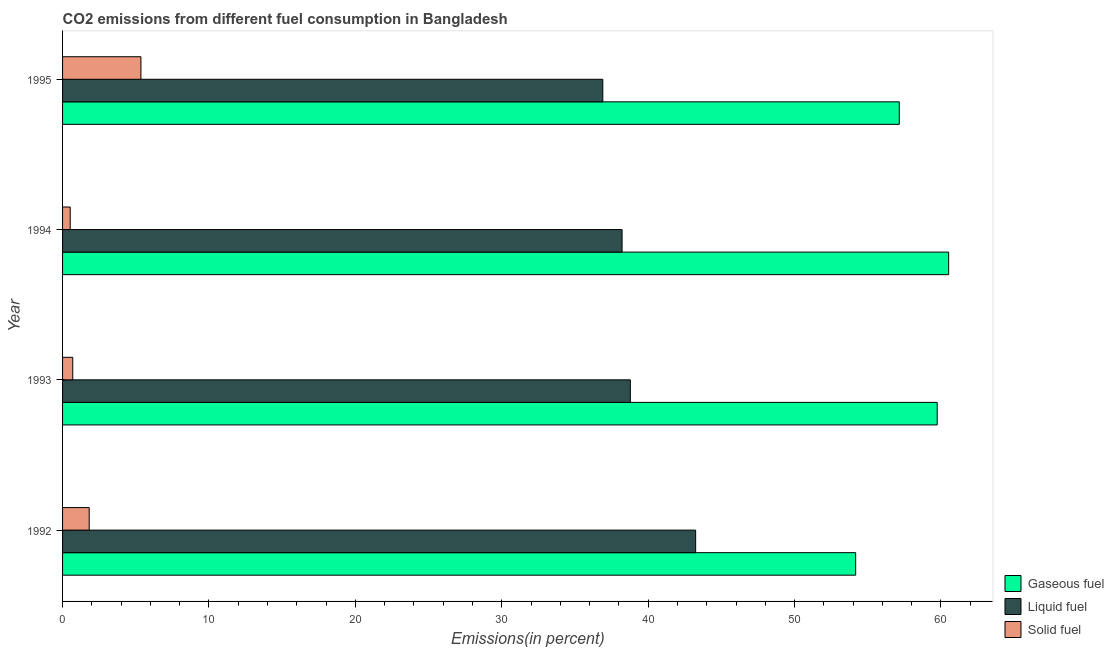How many different coloured bars are there?
Ensure brevity in your answer.  3. How many groups of bars are there?
Offer a very short reply. 4. Are the number of bars per tick equal to the number of legend labels?
Offer a very short reply. Yes. How many bars are there on the 2nd tick from the top?
Offer a very short reply. 3. How many bars are there on the 3rd tick from the bottom?
Provide a short and direct response. 3. What is the label of the 4th group of bars from the top?
Offer a very short reply. 1992. In how many cases, is the number of bars for a given year not equal to the number of legend labels?
Give a very brief answer. 0. What is the percentage of solid fuel emission in 1992?
Provide a short and direct response. 1.82. Across all years, what is the maximum percentage of solid fuel emission?
Offer a very short reply. 5.35. Across all years, what is the minimum percentage of solid fuel emission?
Your answer should be compact. 0.52. What is the total percentage of gaseous fuel emission in the graph?
Make the answer very short. 231.59. What is the difference between the percentage of liquid fuel emission in 1992 and that in 1995?
Provide a succinct answer. 6.34. What is the difference between the percentage of solid fuel emission in 1992 and the percentage of gaseous fuel emission in 1995?
Keep it short and to the point. -55.33. What is the average percentage of solid fuel emission per year?
Keep it short and to the point. 2.1. In the year 1992, what is the difference between the percentage of liquid fuel emission and percentage of gaseous fuel emission?
Keep it short and to the point. -10.93. What is the ratio of the percentage of gaseous fuel emission in 1993 to that in 1994?
Offer a very short reply. 0.99. What is the difference between the highest and the second highest percentage of gaseous fuel emission?
Keep it short and to the point. 0.78. What is the difference between the highest and the lowest percentage of solid fuel emission?
Your answer should be compact. 4.83. Is the sum of the percentage of liquid fuel emission in 1994 and 1995 greater than the maximum percentage of solid fuel emission across all years?
Provide a short and direct response. Yes. What does the 3rd bar from the top in 1992 represents?
Your response must be concise. Gaseous fuel. What does the 3rd bar from the bottom in 1993 represents?
Provide a succinct answer. Solid fuel. Is it the case that in every year, the sum of the percentage of gaseous fuel emission and percentage of liquid fuel emission is greater than the percentage of solid fuel emission?
Your response must be concise. Yes. Are all the bars in the graph horizontal?
Your answer should be compact. Yes. What is the difference between two consecutive major ticks on the X-axis?
Make the answer very short. 10. Does the graph contain any zero values?
Ensure brevity in your answer.  No. Where does the legend appear in the graph?
Your answer should be very brief. Bottom right. How many legend labels are there?
Give a very brief answer. 3. How are the legend labels stacked?
Offer a very short reply. Vertical. What is the title of the graph?
Give a very brief answer. CO2 emissions from different fuel consumption in Bangladesh. What is the label or title of the X-axis?
Provide a short and direct response. Emissions(in percent). What is the Emissions(in percent) of Gaseous fuel in 1992?
Provide a short and direct response. 54.17. What is the Emissions(in percent) of Liquid fuel in 1992?
Keep it short and to the point. 43.24. What is the Emissions(in percent) of Solid fuel in 1992?
Your response must be concise. 1.82. What is the Emissions(in percent) in Gaseous fuel in 1993?
Provide a succinct answer. 59.74. What is the Emissions(in percent) of Liquid fuel in 1993?
Your answer should be compact. 38.78. What is the Emissions(in percent) of Solid fuel in 1993?
Keep it short and to the point. 0.7. What is the Emissions(in percent) of Gaseous fuel in 1994?
Offer a very short reply. 60.53. What is the Emissions(in percent) in Liquid fuel in 1994?
Your answer should be compact. 38.22. What is the Emissions(in percent) in Solid fuel in 1994?
Provide a short and direct response. 0.52. What is the Emissions(in percent) of Gaseous fuel in 1995?
Give a very brief answer. 57.15. What is the Emissions(in percent) of Liquid fuel in 1995?
Your answer should be compact. 36.9. What is the Emissions(in percent) of Solid fuel in 1995?
Give a very brief answer. 5.35. Across all years, what is the maximum Emissions(in percent) in Gaseous fuel?
Ensure brevity in your answer.  60.53. Across all years, what is the maximum Emissions(in percent) in Liquid fuel?
Keep it short and to the point. 43.24. Across all years, what is the maximum Emissions(in percent) in Solid fuel?
Give a very brief answer. 5.35. Across all years, what is the minimum Emissions(in percent) of Gaseous fuel?
Offer a very short reply. 54.17. Across all years, what is the minimum Emissions(in percent) in Liquid fuel?
Make the answer very short. 36.9. Across all years, what is the minimum Emissions(in percent) in Solid fuel?
Offer a very short reply. 0.52. What is the total Emissions(in percent) of Gaseous fuel in the graph?
Offer a very short reply. 231.59. What is the total Emissions(in percent) of Liquid fuel in the graph?
Your answer should be compact. 157.15. What is the total Emissions(in percent) in Solid fuel in the graph?
Give a very brief answer. 8.39. What is the difference between the Emissions(in percent) in Gaseous fuel in 1992 and that in 1993?
Your answer should be compact. -5.57. What is the difference between the Emissions(in percent) in Liquid fuel in 1992 and that in 1993?
Offer a terse response. 4.46. What is the difference between the Emissions(in percent) in Solid fuel in 1992 and that in 1993?
Provide a short and direct response. 1.12. What is the difference between the Emissions(in percent) in Gaseous fuel in 1992 and that in 1994?
Provide a succinct answer. -6.35. What is the difference between the Emissions(in percent) in Liquid fuel in 1992 and that in 1994?
Ensure brevity in your answer.  5.03. What is the difference between the Emissions(in percent) in Solid fuel in 1992 and that in 1994?
Offer a terse response. 1.3. What is the difference between the Emissions(in percent) in Gaseous fuel in 1992 and that in 1995?
Provide a succinct answer. -2.98. What is the difference between the Emissions(in percent) in Liquid fuel in 1992 and that in 1995?
Keep it short and to the point. 6.34. What is the difference between the Emissions(in percent) in Solid fuel in 1992 and that in 1995?
Provide a succinct answer. -3.53. What is the difference between the Emissions(in percent) of Gaseous fuel in 1993 and that in 1994?
Your answer should be compact. -0.78. What is the difference between the Emissions(in percent) in Liquid fuel in 1993 and that in 1994?
Provide a succinct answer. 0.56. What is the difference between the Emissions(in percent) in Solid fuel in 1993 and that in 1994?
Offer a very short reply. 0.17. What is the difference between the Emissions(in percent) of Gaseous fuel in 1993 and that in 1995?
Your answer should be very brief. 2.59. What is the difference between the Emissions(in percent) of Liquid fuel in 1993 and that in 1995?
Your response must be concise. 1.88. What is the difference between the Emissions(in percent) of Solid fuel in 1993 and that in 1995?
Make the answer very short. -4.66. What is the difference between the Emissions(in percent) in Gaseous fuel in 1994 and that in 1995?
Provide a succinct answer. 3.37. What is the difference between the Emissions(in percent) of Liquid fuel in 1994 and that in 1995?
Your answer should be very brief. 1.32. What is the difference between the Emissions(in percent) in Solid fuel in 1994 and that in 1995?
Ensure brevity in your answer.  -4.83. What is the difference between the Emissions(in percent) of Gaseous fuel in 1992 and the Emissions(in percent) of Liquid fuel in 1993?
Provide a short and direct response. 15.39. What is the difference between the Emissions(in percent) of Gaseous fuel in 1992 and the Emissions(in percent) of Solid fuel in 1993?
Your answer should be compact. 53.48. What is the difference between the Emissions(in percent) in Liquid fuel in 1992 and the Emissions(in percent) in Solid fuel in 1993?
Make the answer very short. 42.55. What is the difference between the Emissions(in percent) of Gaseous fuel in 1992 and the Emissions(in percent) of Liquid fuel in 1994?
Keep it short and to the point. 15.96. What is the difference between the Emissions(in percent) of Gaseous fuel in 1992 and the Emissions(in percent) of Solid fuel in 1994?
Keep it short and to the point. 53.65. What is the difference between the Emissions(in percent) in Liquid fuel in 1992 and the Emissions(in percent) in Solid fuel in 1994?
Your answer should be compact. 42.72. What is the difference between the Emissions(in percent) of Gaseous fuel in 1992 and the Emissions(in percent) of Liquid fuel in 1995?
Your response must be concise. 17.27. What is the difference between the Emissions(in percent) of Gaseous fuel in 1992 and the Emissions(in percent) of Solid fuel in 1995?
Ensure brevity in your answer.  48.82. What is the difference between the Emissions(in percent) of Liquid fuel in 1992 and the Emissions(in percent) of Solid fuel in 1995?
Provide a succinct answer. 37.89. What is the difference between the Emissions(in percent) of Gaseous fuel in 1993 and the Emissions(in percent) of Liquid fuel in 1994?
Your response must be concise. 21.53. What is the difference between the Emissions(in percent) in Gaseous fuel in 1993 and the Emissions(in percent) in Solid fuel in 1994?
Your response must be concise. 59.22. What is the difference between the Emissions(in percent) in Liquid fuel in 1993 and the Emissions(in percent) in Solid fuel in 1994?
Offer a very short reply. 38.26. What is the difference between the Emissions(in percent) in Gaseous fuel in 1993 and the Emissions(in percent) in Liquid fuel in 1995?
Provide a succinct answer. 22.84. What is the difference between the Emissions(in percent) in Gaseous fuel in 1993 and the Emissions(in percent) in Solid fuel in 1995?
Your response must be concise. 54.39. What is the difference between the Emissions(in percent) in Liquid fuel in 1993 and the Emissions(in percent) in Solid fuel in 1995?
Make the answer very short. 33.43. What is the difference between the Emissions(in percent) in Gaseous fuel in 1994 and the Emissions(in percent) in Liquid fuel in 1995?
Provide a short and direct response. 23.62. What is the difference between the Emissions(in percent) of Gaseous fuel in 1994 and the Emissions(in percent) of Solid fuel in 1995?
Provide a short and direct response. 55.17. What is the difference between the Emissions(in percent) of Liquid fuel in 1994 and the Emissions(in percent) of Solid fuel in 1995?
Offer a very short reply. 32.87. What is the average Emissions(in percent) in Gaseous fuel per year?
Your answer should be very brief. 57.9. What is the average Emissions(in percent) in Liquid fuel per year?
Your answer should be very brief. 39.29. What is the average Emissions(in percent) of Solid fuel per year?
Your answer should be very brief. 2.1. In the year 1992, what is the difference between the Emissions(in percent) of Gaseous fuel and Emissions(in percent) of Liquid fuel?
Provide a succinct answer. 10.93. In the year 1992, what is the difference between the Emissions(in percent) in Gaseous fuel and Emissions(in percent) in Solid fuel?
Make the answer very short. 52.36. In the year 1992, what is the difference between the Emissions(in percent) of Liquid fuel and Emissions(in percent) of Solid fuel?
Your answer should be compact. 41.43. In the year 1993, what is the difference between the Emissions(in percent) in Gaseous fuel and Emissions(in percent) in Liquid fuel?
Offer a terse response. 20.96. In the year 1993, what is the difference between the Emissions(in percent) of Gaseous fuel and Emissions(in percent) of Solid fuel?
Your answer should be compact. 59.05. In the year 1993, what is the difference between the Emissions(in percent) of Liquid fuel and Emissions(in percent) of Solid fuel?
Make the answer very short. 38.09. In the year 1994, what is the difference between the Emissions(in percent) in Gaseous fuel and Emissions(in percent) in Liquid fuel?
Your answer should be compact. 22.31. In the year 1994, what is the difference between the Emissions(in percent) in Gaseous fuel and Emissions(in percent) in Solid fuel?
Provide a short and direct response. 60. In the year 1994, what is the difference between the Emissions(in percent) in Liquid fuel and Emissions(in percent) in Solid fuel?
Ensure brevity in your answer.  37.7. In the year 1995, what is the difference between the Emissions(in percent) in Gaseous fuel and Emissions(in percent) in Liquid fuel?
Make the answer very short. 20.25. In the year 1995, what is the difference between the Emissions(in percent) of Gaseous fuel and Emissions(in percent) of Solid fuel?
Give a very brief answer. 51.8. In the year 1995, what is the difference between the Emissions(in percent) in Liquid fuel and Emissions(in percent) in Solid fuel?
Offer a terse response. 31.55. What is the ratio of the Emissions(in percent) in Gaseous fuel in 1992 to that in 1993?
Provide a succinct answer. 0.91. What is the ratio of the Emissions(in percent) of Liquid fuel in 1992 to that in 1993?
Ensure brevity in your answer.  1.11. What is the ratio of the Emissions(in percent) in Solid fuel in 1992 to that in 1993?
Make the answer very short. 2.62. What is the ratio of the Emissions(in percent) of Gaseous fuel in 1992 to that in 1994?
Your answer should be very brief. 0.9. What is the ratio of the Emissions(in percent) of Liquid fuel in 1992 to that in 1994?
Your answer should be very brief. 1.13. What is the ratio of the Emissions(in percent) in Solid fuel in 1992 to that in 1994?
Your answer should be very brief. 3.48. What is the ratio of the Emissions(in percent) in Gaseous fuel in 1992 to that in 1995?
Your answer should be compact. 0.95. What is the ratio of the Emissions(in percent) in Liquid fuel in 1992 to that in 1995?
Provide a short and direct response. 1.17. What is the ratio of the Emissions(in percent) in Solid fuel in 1992 to that in 1995?
Offer a terse response. 0.34. What is the ratio of the Emissions(in percent) of Gaseous fuel in 1993 to that in 1994?
Offer a terse response. 0.99. What is the ratio of the Emissions(in percent) of Liquid fuel in 1993 to that in 1994?
Provide a succinct answer. 1.01. What is the ratio of the Emissions(in percent) of Solid fuel in 1993 to that in 1994?
Provide a short and direct response. 1.33. What is the ratio of the Emissions(in percent) in Gaseous fuel in 1993 to that in 1995?
Give a very brief answer. 1.05. What is the ratio of the Emissions(in percent) in Liquid fuel in 1993 to that in 1995?
Offer a very short reply. 1.05. What is the ratio of the Emissions(in percent) of Solid fuel in 1993 to that in 1995?
Provide a short and direct response. 0.13. What is the ratio of the Emissions(in percent) of Gaseous fuel in 1994 to that in 1995?
Offer a terse response. 1.06. What is the ratio of the Emissions(in percent) of Liquid fuel in 1994 to that in 1995?
Keep it short and to the point. 1.04. What is the ratio of the Emissions(in percent) of Solid fuel in 1994 to that in 1995?
Offer a terse response. 0.1. What is the difference between the highest and the second highest Emissions(in percent) of Gaseous fuel?
Keep it short and to the point. 0.78. What is the difference between the highest and the second highest Emissions(in percent) in Liquid fuel?
Your response must be concise. 4.46. What is the difference between the highest and the second highest Emissions(in percent) of Solid fuel?
Your answer should be compact. 3.53. What is the difference between the highest and the lowest Emissions(in percent) in Gaseous fuel?
Provide a succinct answer. 6.35. What is the difference between the highest and the lowest Emissions(in percent) in Liquid fuel?
Offer a terse response. 6.34. What is the difference between the highest and the lowest Emissions(in percent) of Solid fuel?
Provide a short and direct response. 4.83. 